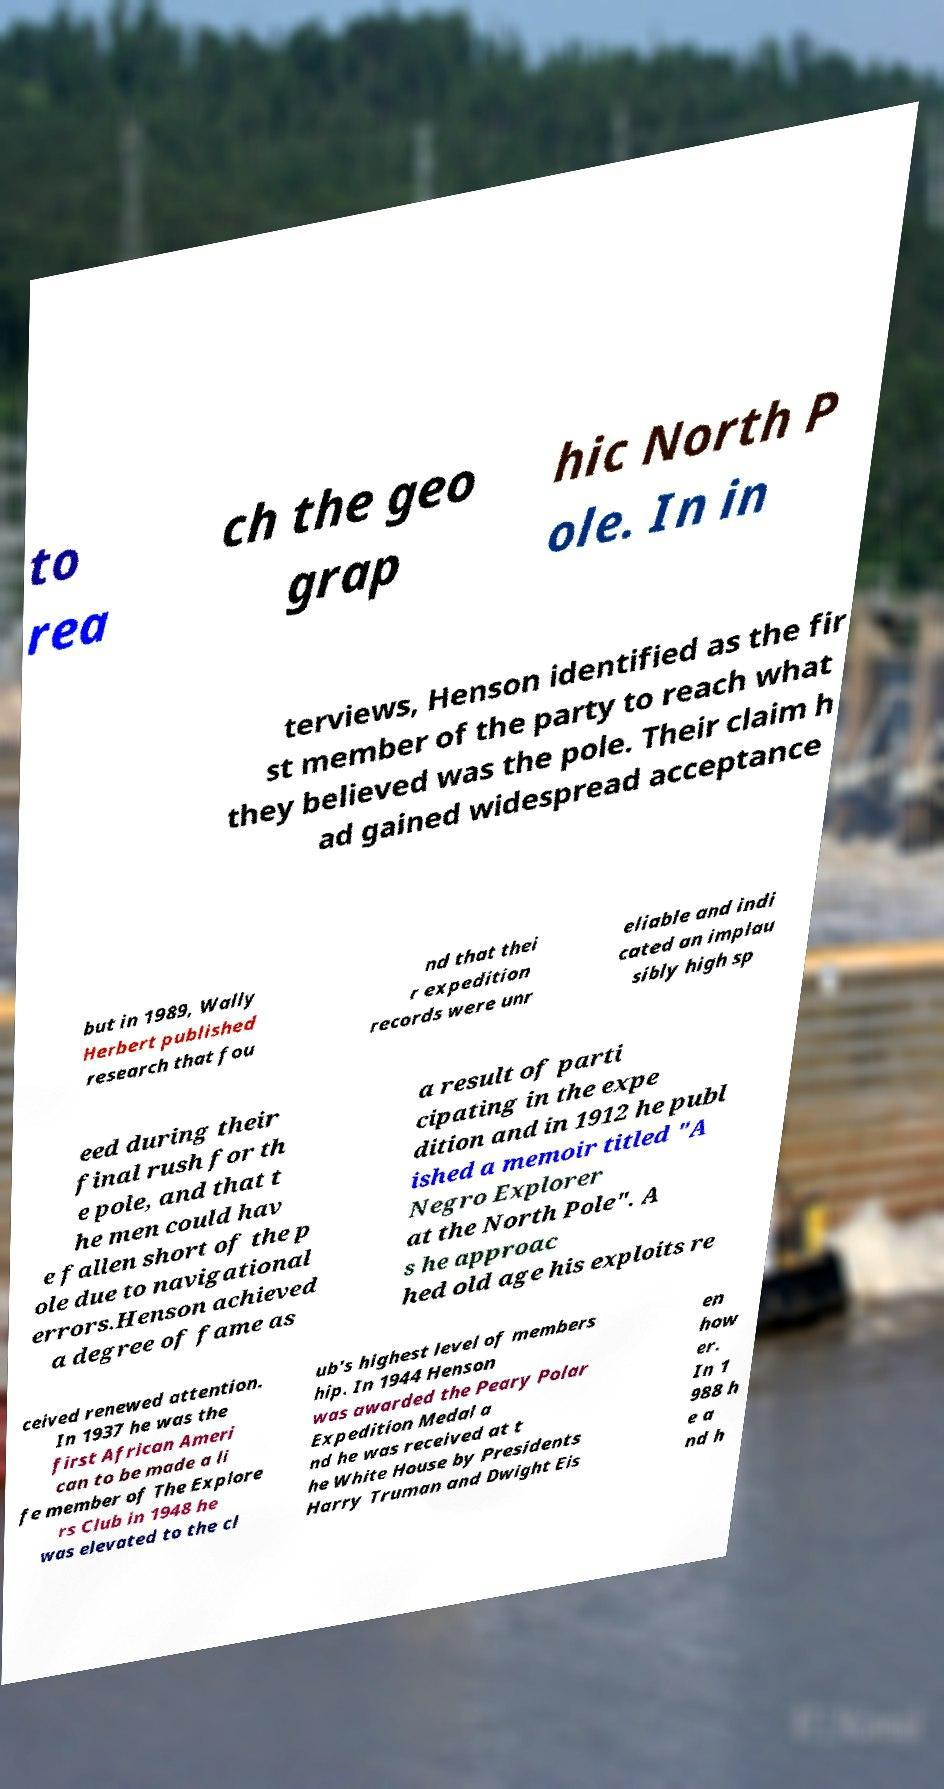Could you assist in decoding the text presented in this image and type it out clearly? to rea ch the geo grap hic North P ole. In in terviews, Henson identified as the fir st member of the party to reach what they believed was the pole. Their claim h ad gained widespread acceptance but in 1989, Wally Herbert published research that fou nd that thei r expedition records were unr eliable and indi cated an implau sibly high sp eed during their final rush for th e pole, and that t he men could hav e fallen short of the p ole due to navigational errors.Henson achieved a degree of fame as a result of parti cipating in the expe dition and in 1912 he publ ished a memoir titled "A Negro Explorer at the North Pole". A s he approac hed old age his exploits re ceived renewed attention. In 1937 he was the first African Ameri can to be made a li fe member of The Explore rs Club in 1948 he was elevated to the cl ub's highest level of members hip. In 1944 Henson was awarded the Peary Polar Expedition Medal a nd he was received at t he White House by Presidents Harry Truman and Dwight Eis en how er. In 1 988 h e a nd h 